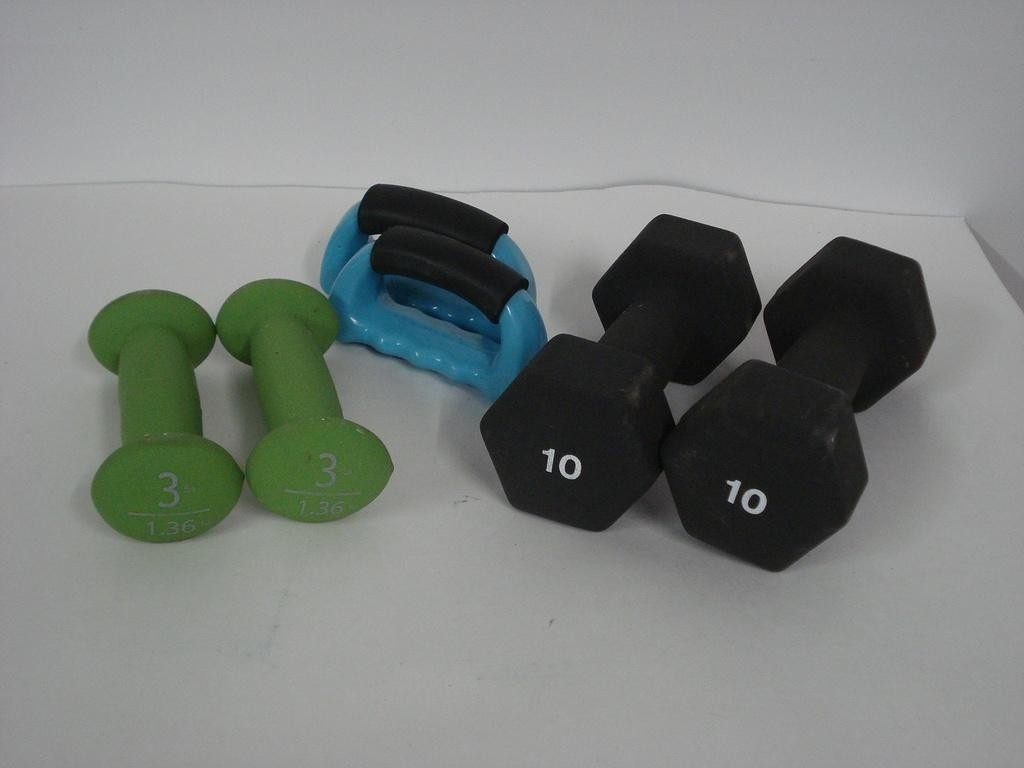How many pairs of dumbbells are visible in the image? There are two pairs of dumbbells in the image. What other object can be seen in the image besides the dumbbells? There is a computer object in the image. Where are the objects placed in the image? The objects are placed on a table. What is the color of the background in the image? The background appears to be white in color. What type of shoes are visible in the image? There are no shoes present in the image. What historical event is depicted in the image? There is no historical event depicted in the image; it features dumbbells, a computer object, and a white background. 